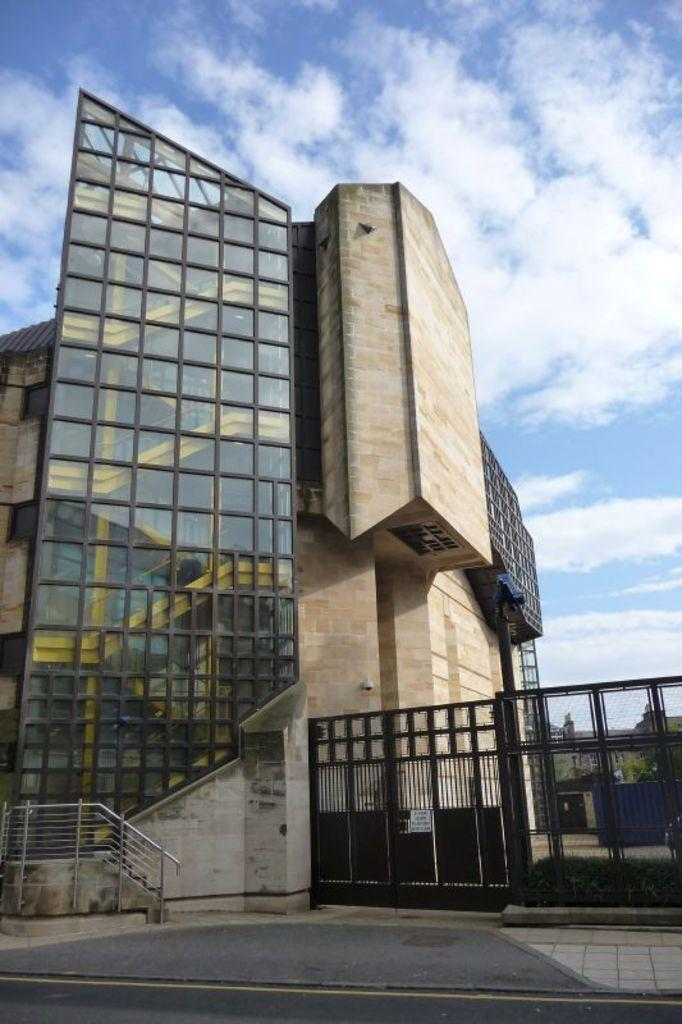What type of structure can be seen in the image? There is a gate, a wall, a fence, and a building visible in the image. What other elements can be seen in the image? There are plants and a tree visible in the image, as well as the sky and clouds in the background. How many bottles of wine are visible in the image? There are no bottles of wine present in the image. Are there any brothers depicted in the image? There is no mention of brothers or any people in the image. 